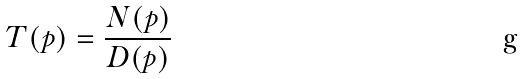<formula> <loc_0><loc_0><loc_500><loc_500>T ( p ) = \frac { N ( p ) } { D ( p ) }</formula> 